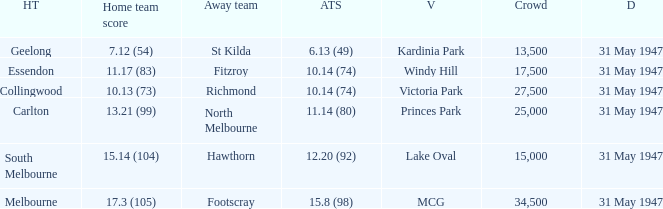What is the listed crowd when hawthorn is away? 1.0. 